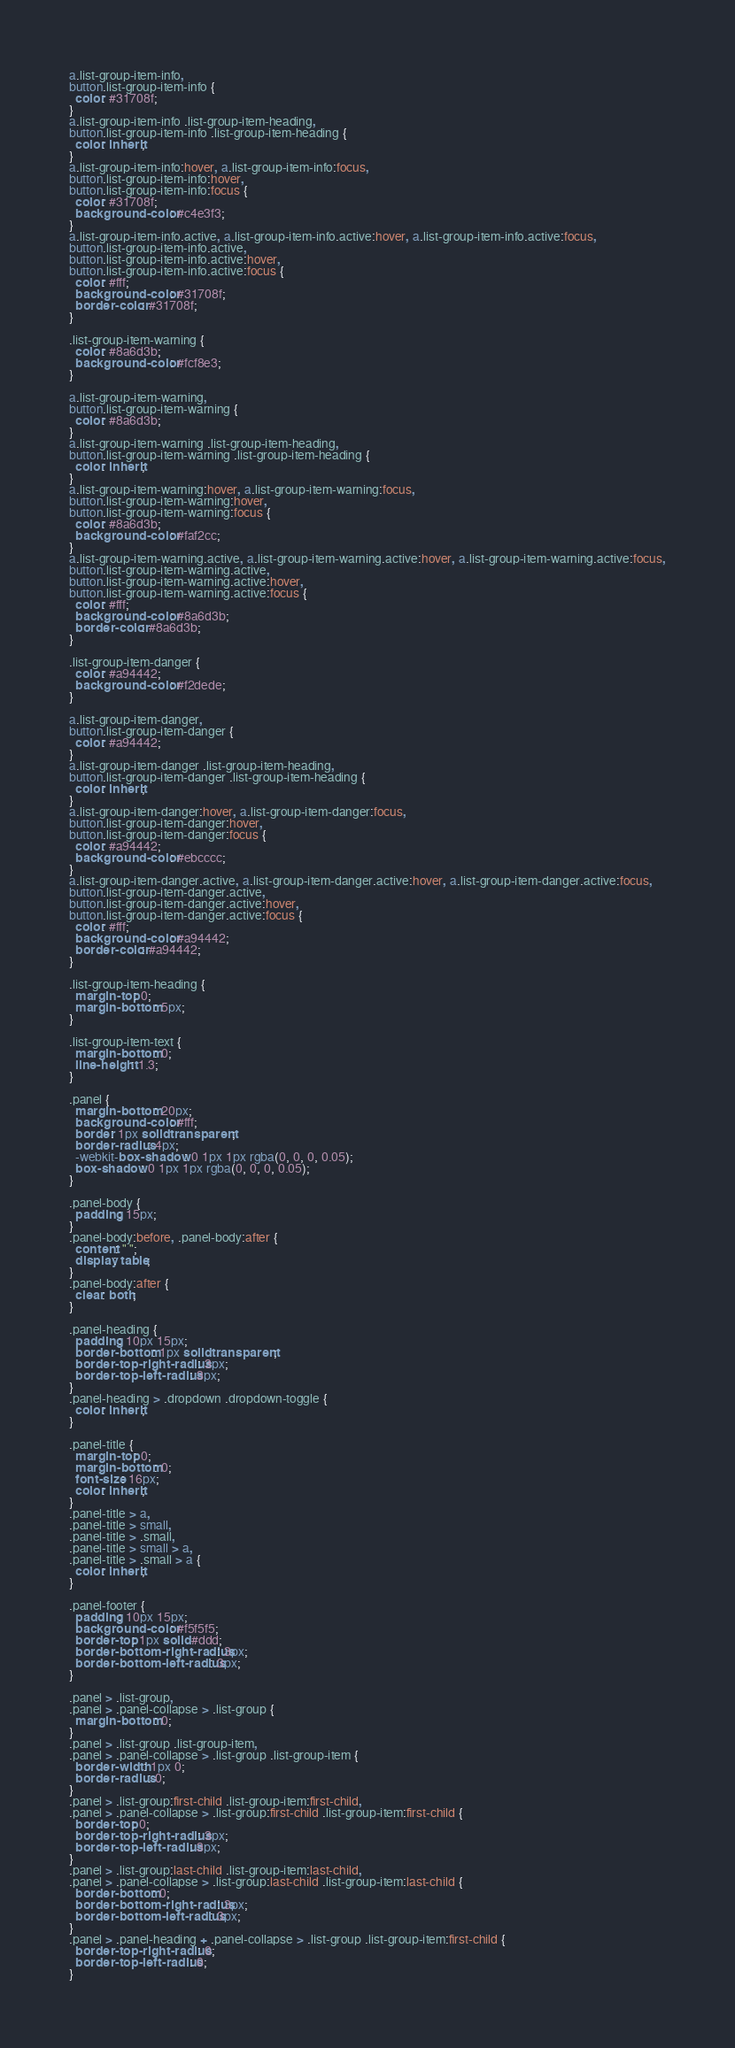Convert code to text. <code><loc_0><loc_0><loc_500><loc_500><_CSS_>
a.list-group-item-info,
button.list-group-item-info {
  color: #31708f;
}
a.list-group-item-info .list-group-item-heading,
button.list-group-item-info .list-group-item-heading {
  color: inherit;
}
a.list-group-item-info:hover, a.list-group-item-info:focus,
button.list-group-item-info:hover,
button.list-group-item-info:focus {
  color: #31708f;
  background-color: #c4e3f3;
}
a.list-group-item-info.active, a.list-group-item-info.active:hover, a.list-group-item-info.active:focus,
button.list-group-item-info.active,
button.list-group-item-info.active:hover,
button.list-group-item-info.active:focus {
  color: #fff;
  background-color: #31708f;
  border-color: #31708f;
}

.list-group-item-warning {
  color: #8a6d3b;
  background-color: #fcf8e3;
}

a.list-group-item-warning,
button.list-group-item-warning {
  color: #8a6d3b;
}
a.list-group-item-warning .list-group-item-heading,
button.list-group-item-warning .list-group-item-heading {
  color: inherit;
}
a.list-group-item-warning:hover, a.list-group-item-warning:focus,
button.list-group-item-warning:hover,
button.list-group-item-warning:focus {
  color: #8a6d3b;
  background-color: #faf2cc;
}
a.list-group-item-warning.active, a.list-group-item-warning.active:hover, a.list-group-item-warning.active:focus,
button.list-group-item-warning.active,
button.list-group-item-warning.active:hover,
button.list-group-item-warning.active:focus {
  color: #fff;
  background-color: #8a6d3b;
  border-color: #8a6d3b;
}

.list-group-item-danger {
  color: #a94442;
  background-color: #f2dede;
}

a.list-group-item-danger,
button.list-group-item-danger {
  color: #a94442;
}
a.list-group-item-danger .list-group-item-heading,
button.list-group-item-danger .list-group-item-heading {
  color: inherit;
}
a.list-group-item-danger:hover, a.list-group-item-danger:focus,
button.list-group-item-danger:hover,
button.list-group-item-danger:focus {
  color: #a94442;
  background-color: #ebcccc;
}
a.list-group-item-danger.active, a.list-group-item-danger.active:hover, a.list-group-item-danger.active:focus,
button.list-group-item-danger.active,
button.list-group-item-danger.active:hover,
button.list-group-item-danger.active:focus {
  color: #fff;
  background-color: #a94442;
  border-color: #a94442;
}

.list-group-item-heading {
  margin-top: 0;
  margin-bottom: 5px;
}

.list-group-item-text {
  margin-bottom: 0;
  line-height: 1.3;
}

.panel {
  margin-bottom: 20px;
  background-color: #fff;
  border: 1px solid transparent;
  border-radius: 4px;
  -webkit-box-shadow: 0 1px 1px rgba(0, 0, 0, 0.05);
  box-shadow: 0 1px 1px rgba(0, 0, 0, 0.05);
}

.panel-body {
  padding: 15px;
}
.panel-body:before, .panel-body:after {
  content: " ";
  display: table;
}
.panel-body:after {
  clear: both;
}

.panel-heading {
  padding: 10px 15px;
  border-bottom: 1px solid transparent;
  border-top-right-radius: 3px;
  border-top-left-radius: 3px;
}
.panel-heading > .dropdown .dropdown-toggle {
  color: inherit;
}

.panel-title {
  margin-top: 0;
  margin-bottom: 0;
  font-size: 16px;
  color: inherit;
}
.panel-title > a,
.panel-title > small,
.panel-title > .small,
.panel-title > small > a,
.panel-title > .small > a {
  color: inherit;
}

.panel-footer {
  padding: 10px 15px;
  background-color: #f5f5f5;
  border-top: 1px solid #ddd;
  border-bottom-right-radius: 3px;
  border-bottom-left-radius: 3px;
}

.panel > .list-group,
.panel > .panel-collapse > .list-group {
  margin-bottom: 0;
}
.panel > .list-group .list-group-item,
.panel > .panel-collapse > .list-group .list-group-item {
  border-width: 1px 0;
  border-radius: 0;
}
.panel > .list-group:first-child .list-group-item:first-child,
.panel > .panel-collapse > .list-group:first-child .list-group-item:first-child {
  border-top: 0;
  border-top-right-radius: 3px;
  border-top-left-radius: 3px;
}
.panel > .list-group:last-child .list-group-item:last-child,
.panel > .panel-collapse > .list-group:last-child .list-group-item:last-child {
  border-bottom: 0;
  border-bottom-right-radius: 3px;
  border-bottom-left-radius: 3px;
}
.panel > .panel-heading + .panel-collapse > .list-group .list-group-item:first-child {
  border-top-right-radius: 0;
  border-top-left-radius: 0;
}
</code> 